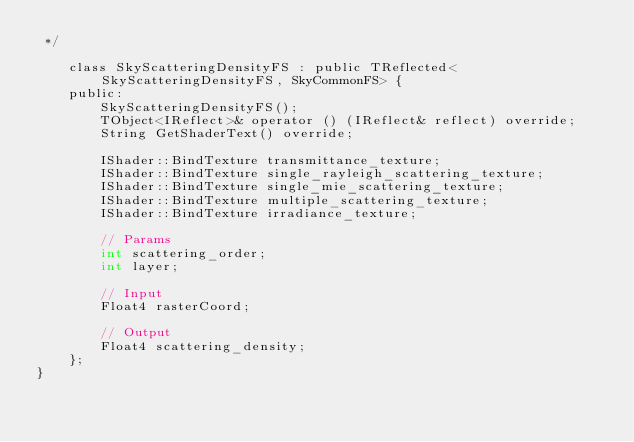Convert code to text. <code><loc_0><loc_0><loc_500><loc_500><_C_> */

	class SkyScatteringDensityFS : public TReflected<SkyScatteringDensityFS, SkyCommonFS> {
	public:
		SkyScatteringDensityFS();
		TObject<IReflect>& operator () (IReflect& reflect) override;
		String GetShaderText() override;

		IShader::BindTexture transmittance_texture;
		IShader::BindTexture single_rayleigh_scattering_texture;
		IShader::BindTexture single_mie_scattering_texture;
		IShader::BindTexture multiple_scattering_texture;
		IShader::BindTexture irradiance_texture;

		// Params
		int scattering_order;
		int layer;

		// Input
		Float4 rasterCoord;

		// Output
		Float4 scattering_density;
	};
}

</code> 